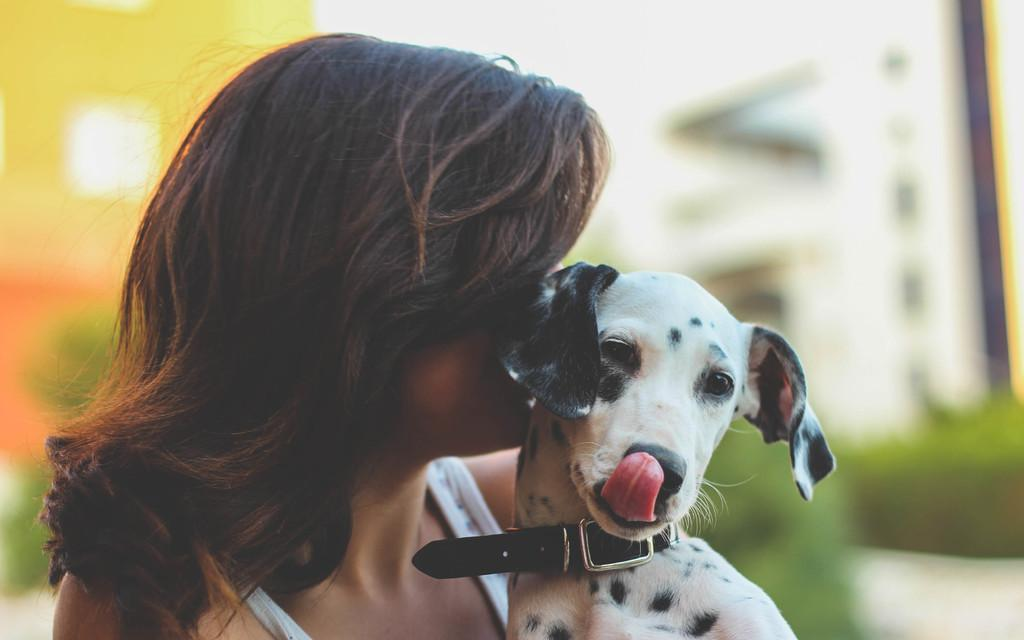Who is present in the image? There is a woman in the image. What is the woman holding in the image? The woman is holding a white dog. What can be seen in the background of the image? There are buildings and plants in the background of the image. How is the background of the image depicted? The background of the image is blurry. What type of science experiment is being conducted with the bells in the image? There are no bells present in the image, so it is not possible to determine if a science experiment is being conducted. 